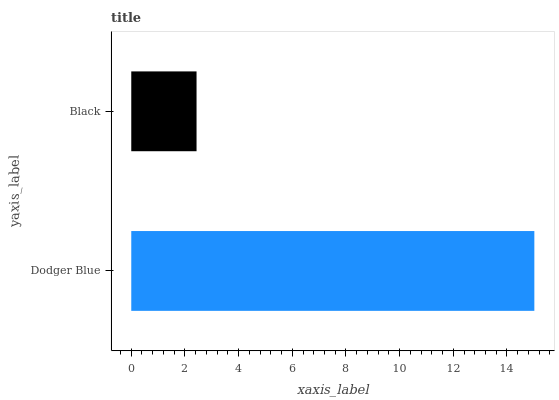Is Black the minimum?
Answer yes or no. Yes. Is Dodger Blue the maximum?
Answer yes or no. Yes. Is Black the maximum?
Answer yes or no. No. Is Dodger Blue greater than Black?
Answer yes or no. Yes. Is Black less than Dodger Blue?
Answer yes or no. Yes. Is Black greater than Dodger Blue?
Answer yes or no. No. Is Dodger Blue less than Black?
Answer yes or no. No. Is Dodger Blue the high median?
Answer yes or no. Yes. Is Black the low median?
Answer yes or no. Yes. Is Black the high median?
Answer yes or no. No. Is Dodger Blue the low median?
Answer yes or no. No. 